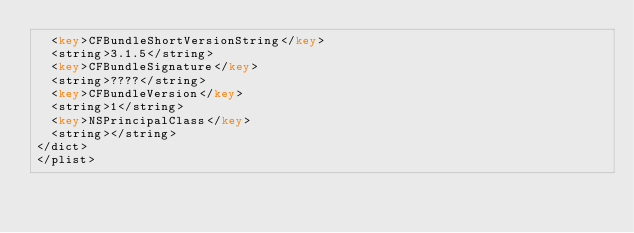<code> <loc_0><loc_0><loc_500><loc_500><_XML_>  <key>CFBundleShortVersionString</key>
  <string>3.1.5</string>
  <key>CFBundleSignature</key>
  <string>????</string>
  <key>CFBundleVersion</key>
  <string>1</string>
  <key>NSPrincipalClass</key>
  <string></string>
</dict>
</plist>
</code> 